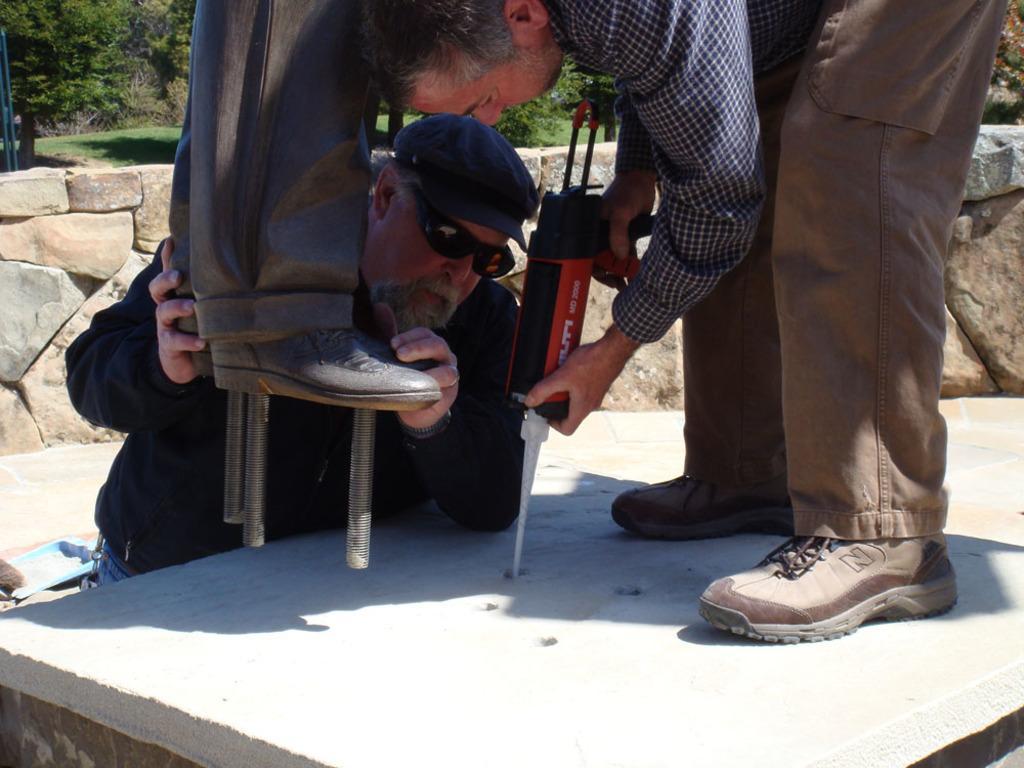Can you describe this image briefly? In this picture we can see two persons here, there is a drilling machine in his hands, in the background there are some trees, we can see grass here, this man wore a cap and goggles. 